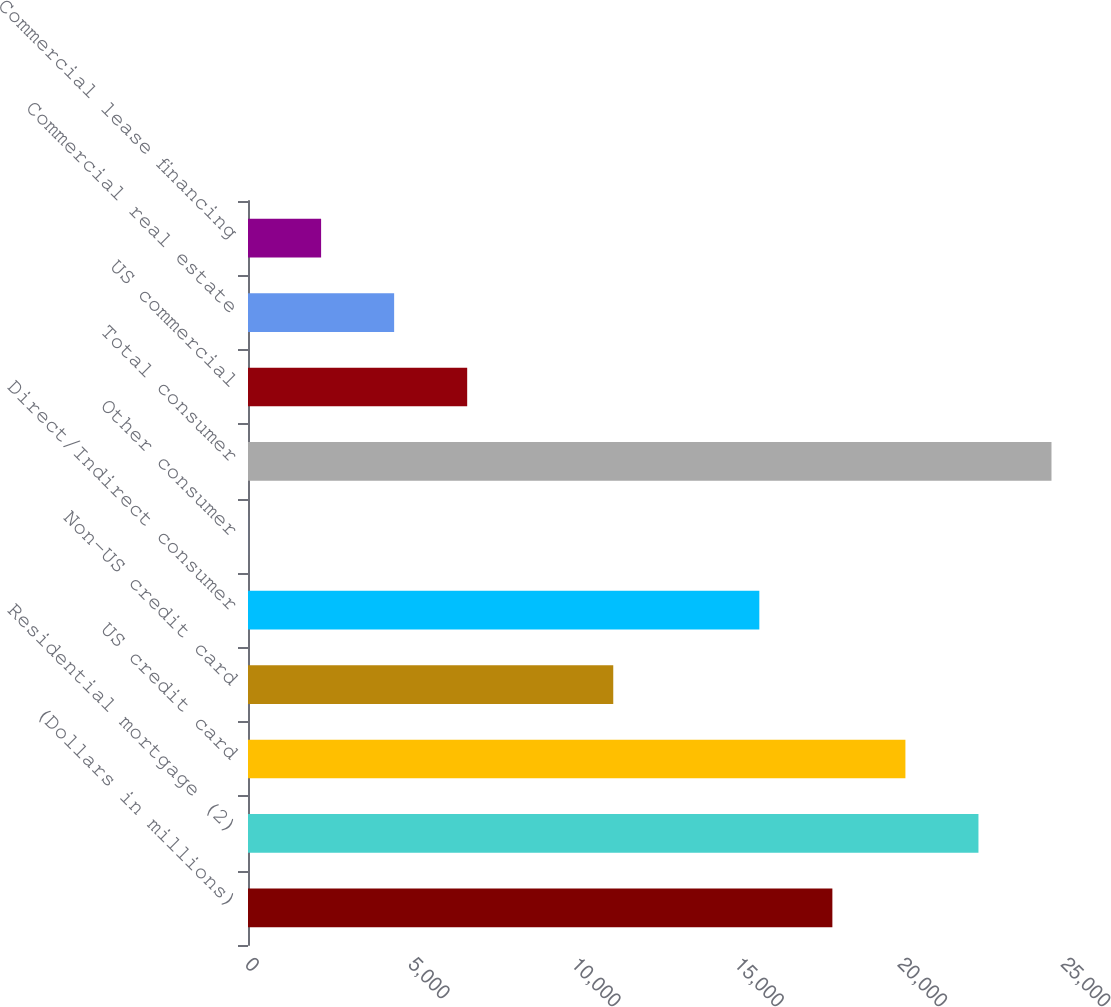Convert chart to OTSL. <chart><loc_0><loc_0><loc_500><loc_500><bar_chart><fcel>(Dollars in millions)<fcel>Residential mortgage (2)<fcel>US credit card<fcel>Non-US credit card<fcel>Direct/Indirect consumer<fcel>Other consumer<fcel>Total consumer<fcel>US commercial<fcel>Commercial real estate<fcel>Commercial lease financing<nl><fcel>17903.6<fcel>22379<fcel>20141.3<fcel>11190.5<fcel>15665.9<fcel>2<fcel>24616.7<fcel>6715.1<fcel>4477.4<fcel>2239.7<nl></chart> 